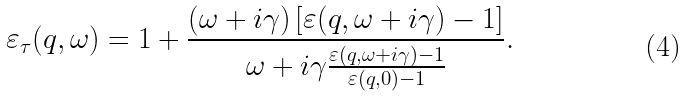<formula> <loc_0><loc_0><loc_500><loc_500>\varepsilon _ { \tau } ( q , \omega ) = 1 + \frac { ( \omega + i \gamma ) \left [ \varepsilon ( q , \omega + i \gamma ) - 1 \right ] } { \omega + i \gamma \frac { \varepsilon ( q , \omega + i \gamma ) - 1 } { \varepsilon ( q , 0 ) - 1 } } .</formula> 